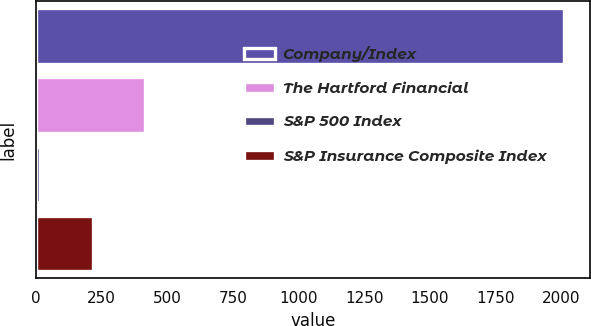Convert chart to OTSL. <chart><loc_0><loc_0><loc_500><loc_500><bar_chart><fcel>Company/Index<fcel>The Hartford Financial<fcel>S&P 500 Index<fcel>S&P Insurance Composite Index<nl><fcel>2012<fcel>415.2<fcel>16<fcel>215.6<nl></chart> 